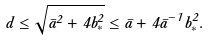<formula> <loc_0><loc_0><loc_500><loc_500>d \leq \sqrt { \bar { a } ^ { 2 } + 4 b _ { * } ^ { 2 } } \leq \bar { a } + 4 \bar { a } ^ { - 1 } b _ { * } ^ { 2 } .</formula> 